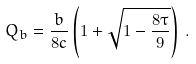<formula> <loc_0><loc_0><loc_500><loc_500>Q _ { b } = \frac { b } { 8 c } \left ( 1 + \sqrt { 1 - \frac { 8 \tau } { 9 } } \right ) \, .</formula> 